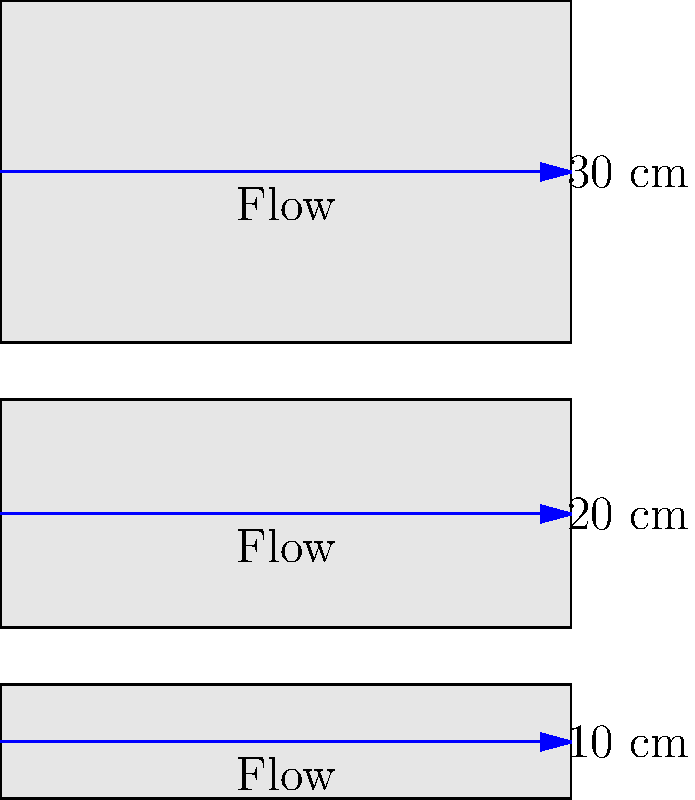In your past engineering studies, you might recall the relationship between pipe diameter and flow rate. Given three pipes with diameters of 10 cm, 20 cm, and 30 cm, all other factors being equal, how does the flow rate in the 30 cm pipe compare to the flow rate in the 10 cm pipe? To solve this problem, we need to recall the relationship between pipe diameter and flow rate. The process is as follows:

1. Remember that flow rate is proportional to the cross-sectional area of the pipe.

2. The cross-sectional area of a circular pipe is given by the formula: $A = \pi r^2$, where $r$ is the radius.

3. The radius is half the diameter. So for the 10 cm pipe, $r = 5$ cm, and for the 30 cm pipe, $r = 15$ cm.

4. Calculate the ratio of the areas:

   $$\frac{A_{30}}{A_{10}} = \frac{\pi (15\text{ cm})^2}{\pi (5\text{ cm})^2} = \frac{225\pi\text{ cm}^2}{25\pi\text{ cm}^2} = 9$$

5. Since flow rate is proportional to area, the flow rate in the 30 cm pipe will be 9 times greater than in the 10 cm pipe.

This relationship demonstrates how a relatively small increase in pipe diameter can result in a significant increase in flow capacity, which is crucial in designing efficient water distribution systems.
Answer: 9 times greater 